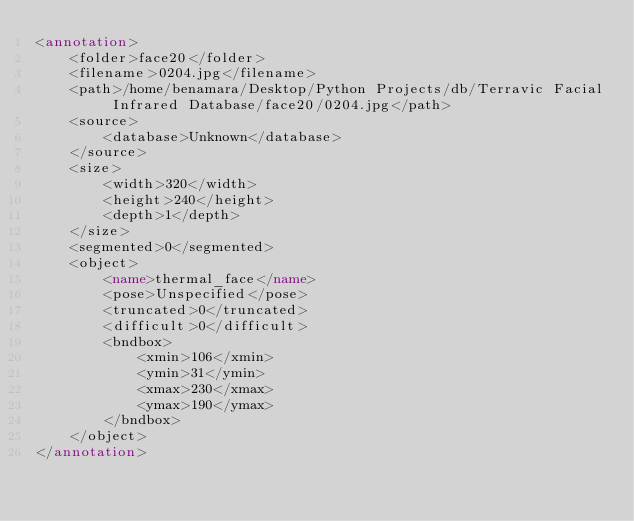<code> <loc_0><loc_0><loc_500><loc_500><_XML_><annotation>
	<folder>face20</folder>
	<filename>0204.jpg</filename>
	<path>/home/benamara/Desktop/Python Projects/db/Terravic Facial Infrared Database/face20/0204.jpg</path>
	<source>
		<database>Unknown</database>
	</source>
	<size>
		<width>320</width>
		<height>240</height>
		<depth>1</depth>
	</size>
	<segmented>0</segmented>
	<object>
		<name>thermal_face</name>
		<pose>Unspecified</pose>
		<truncated>0</truncated>
		<difficult>0</difficult>
		<bndbox>
			<xmin>106</xmin>
			<ymin>31</ymin>
			<xmax>230</xmax>
			<ymax>190</ymax>
		</bndbox>
	</object>
</annotation>
</code> 